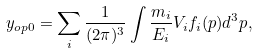Convert formula to latex. <formula><loc_0><loc_0><loc_500><loc_500>y _ { o p 0 } = \sum _ { i } { \frac { 1 } { ( 2 \pi ) ^ { 3 } } \int { \frac { m _ { i } } { E _ { i } } V _ { i } f _ { i } ( p ) d ^ { 3 } p } } ,</formula> 